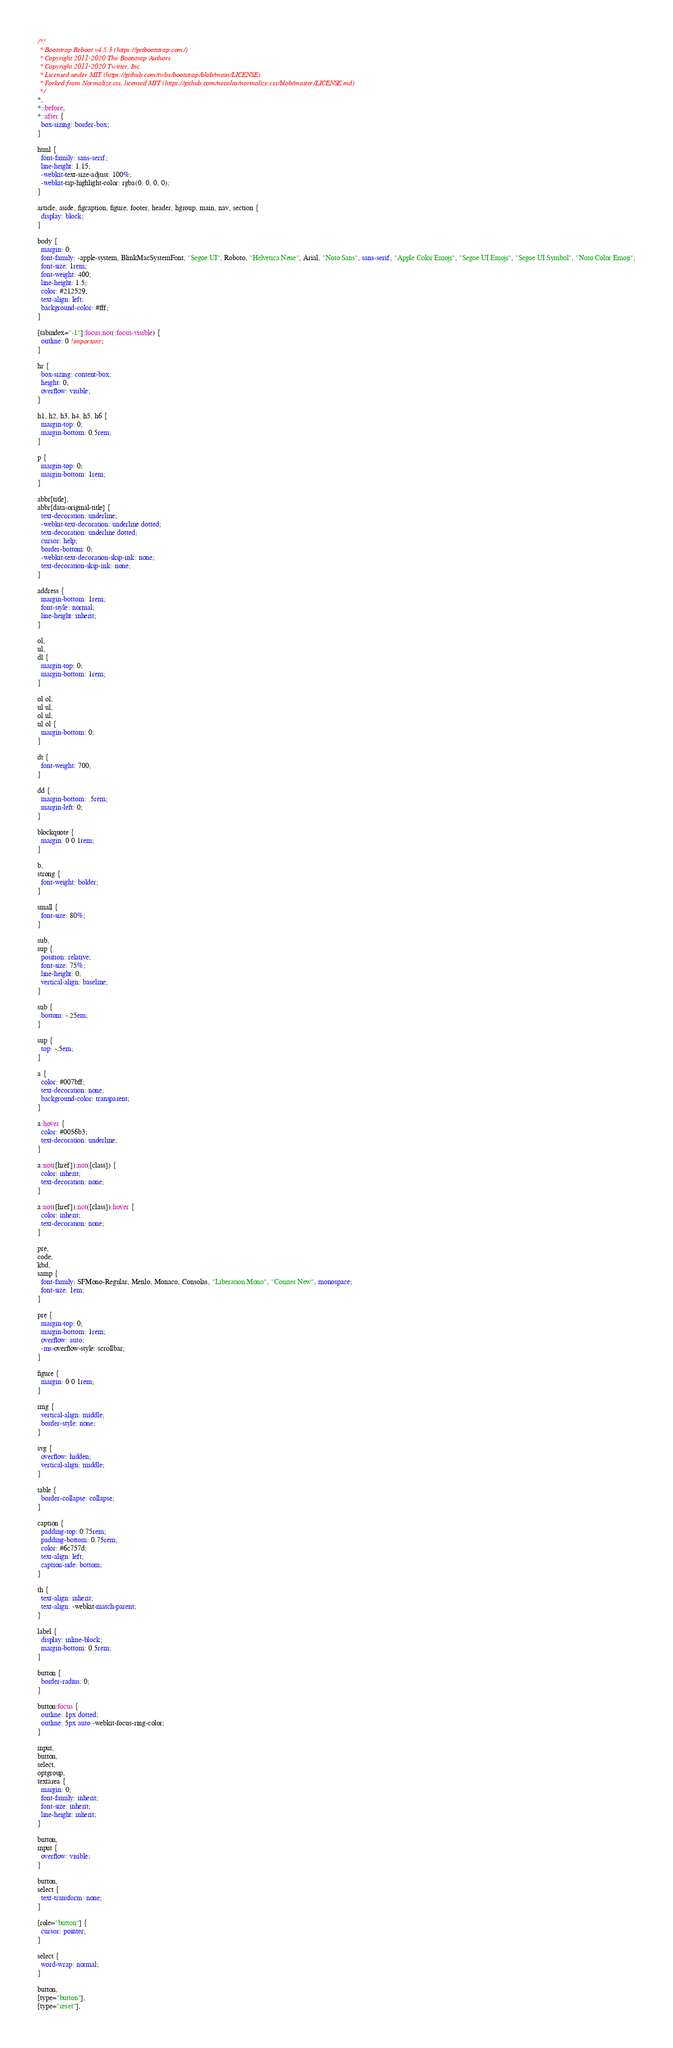<code> <loc_0><loc_0><loc_500><loc_500><_CSS_>/*!
 * Bootstrap Reboot v4.5.3 (https://getbootstrap.com/)
 * Copyright 2011-2020 The Bootstrap Authors
 * Copyright 2011-2020 Twitter, Inc.
 * Licensed under MIT (https://github.com/twbs/bootstrap/blob/main/LICENSE)
 * Forked from Normalize.css, licensed MIT (https://github.com/necolas/normalize.css/blob/master/LICENSE.md)
 */
*,
*::before,
*::after {
  box-sizing: border-box;
}

html {
  font-family: sans-serif;
  line-height: 1.15;
  -webkit-text-size-adjust: 100%;
  -webkit-tap-highlight-color: rgba(0, 0, 0, 0);
}

article, aside, figcaption, figure, footer, header, hgroup, main, nav, section {
  display: block;
}

body {
  margin: 0;
  font-family: -apple-system, BlinkMacSystemFont, "Segoe UI", Roboto, "Helvetica Neue", Arial, "Noto Sans", sans-serif, "Apple Color Emoji", "Segoe UI Emoji", "Segoe UI Symbol", "Noto Color Emoji";
  font-size: 1rem;
  font-weight: 400;
  line-height: 1.5;
  color: #212529;
  text-align: left;
  background-color: #fff;
}

[tabindex="-1"]:focus:not(:focus-visible) {
  outline: 0 !important;
}

hr {
  box-sizing: content-box;
  height: 0;
  overflow: visible;
}

h1, h2, h3, h4, h5, h6 {
  margin-top: 0;
  margin-bottom: 0.5rem;
}

p {
  margin-top: 0;
  margin-bottom: 1rem;
}

abbr[title],
abbr[data-original-title] {
  text-decoration: underline;
  -webkit-text-decoration: underline dotted;
  text-decoration: underline dotted;
  cursor: help;
  border-bottom: 0;
  -webkit-text-decoration-skip-ink: none;
  text-decoration-skip-ink: none;
}

address {
  margin-bottom: 1rem;
  font-style: normal;
  line-height: inherit;
}

ol,
ul,
dl {
  margin-top: 0;
  margin-bottom: 1rem;
}

ol ol,
ul ul,
ol ul,
ul ol {
  margin-bottom: 0;
}

dt {
  font-weight: 700;
}

dd {
  margin-bottom: .5rem;
  margin-left: 0;
}

blockquote {
  margin: 0 0 1rem;
}

b,
strong {
  font-weight: bolder;
}

small {
  font-size: 80%;
}

sub,
sup {
  position: relative;
  font-size: 75%;
  line-height: 0;
  vertical-align: baseline;
}

sub {
  bottom: -.25em;
}

sup {
  top: -.5em;
}

a {
  color: #007bff;
  text-decoration: none;
  background-color: transparent;
}

a:hover {
  color: #0056b3;
  text-decoration: underline;
}

a:not([href]):not([class]) {
  color: inherit;
  text-decoration: none;
}

a:not([href]):not([class]):hover {
  color: inherit;
  text-decoration: none;
}

pre,
code,
kbd,
samp {
  font-family: SFMono-Regular, Menlo, Monaco, Consolas, "Liberation Mono", "Courier New", monospace;
  font-size: 1em;
}

pre {
  margin-top: 0;
  margin-bottom: 1rem;
  overflow: auto;
  -ms-overflow-style: scrollbar;
}

figure {
  margin: 0 0 1rem;
}

img {
  vertical-align: middle;
  border-style: none;
}

svg {
  overflow: hidden;
  vertical-align: middle;
}

table {
  border-collapse: collapse;
}

caption {
  padding-top: 0.75rem;
  padding-bottom: 0.75rem;
  color: #6c757d;
  text-align: left;
  caption-side: bottom;
}

th {
  text-align: inherit;
  text-align: -webkit-match-parent;
}

label {
  display: inline-block;
  margin-bottom: 0.5rem;
}

button {
  border-radius: 0;
}

button:focus {
  outline: 1px dotted;
  outline: 5px auto -webkit-focus-ring-color;
}

input,
button,
select,
optgroup,
textarea {
  margin: 0;
  font-family: inherit;
  font-size: inherit;
  line-height: inherit;
}

button,
input {
  overflow: visible;
}

button,
select {
  text-transform: none;
}

[role="button"] {
  cursor: pointer;
}

select {
  word-wrap: normal;
}

button,
[type="button"],
[type="reset"],</code> 